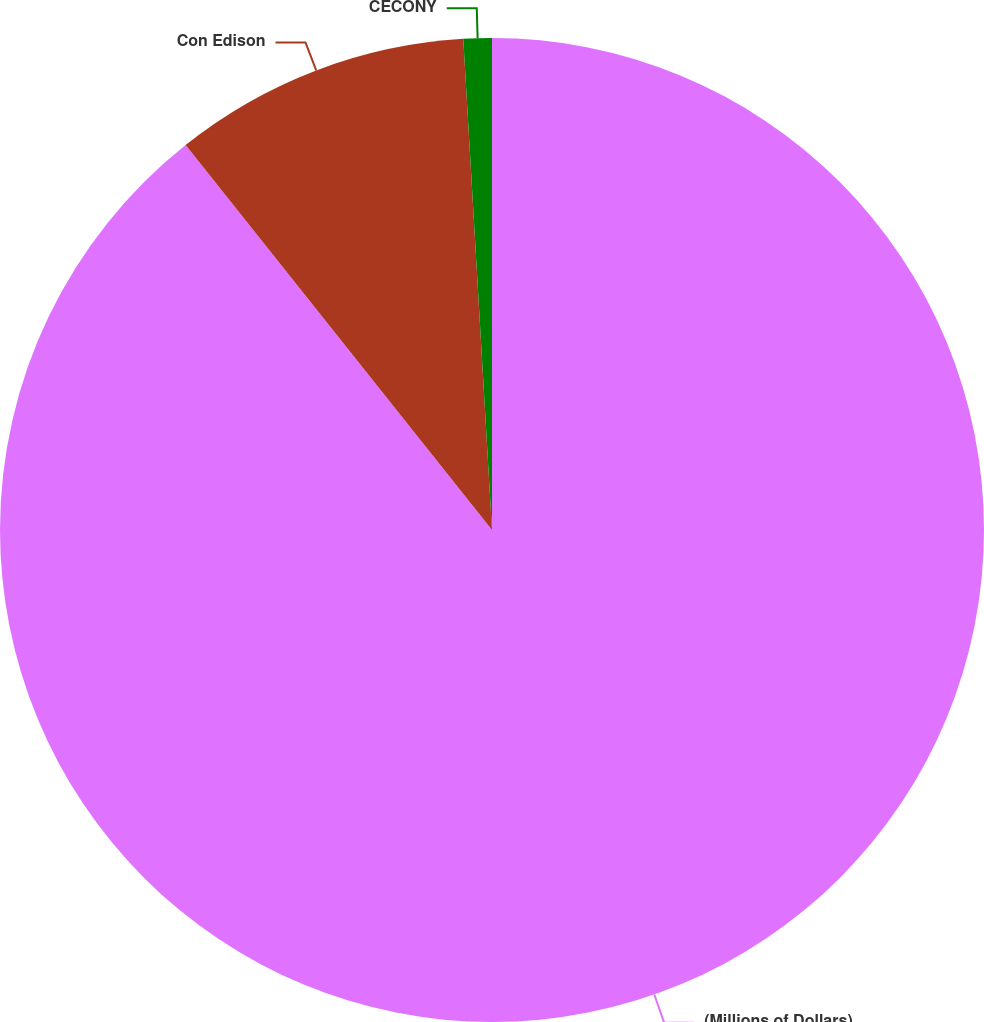<chart> <loc_0><loc_0><loc_500><loc_500><pie_chart><fcel>(Millions of Dollars)<fcel>Con Edison<fcel>CECONY<nl><fcel>89.3%<fcel>9.77%<fcel>0.93%<nl></chart> 